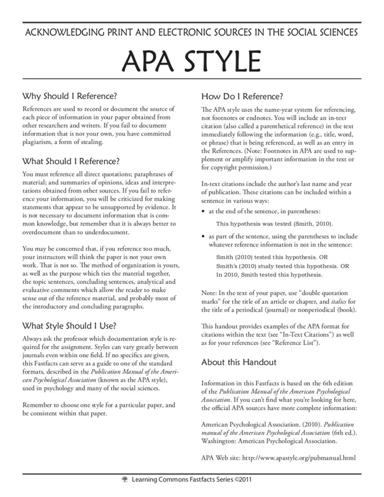What is the main subject of the text in the image?
 The main subject of the text is acknowledging print and electronic sources in the social sciences using APA style. How does APA style differ from other referencing styles? APA style uses the name-year system for referencing instead of footnotes or endnotes. It includes in-text citations, usually in parentheses, as well as an entry in the References section. Why is it essential to provide correct references in academic writing? Providing correct references in academic writing is essential to record or document the source of each piece of information you have obtained from other researchers and writers. It helps avoid plagiarism, a form of stealing. Proper referencing also adds credibility to your work by supporting your statements with evidence from reliable sources. When should you use double quotation marks in APA style in the text of your paper? In the text of your paper, use double quotation marks for the title of an article or chapter, as well as for the title of a periodical, journal, or non-periodical book. 